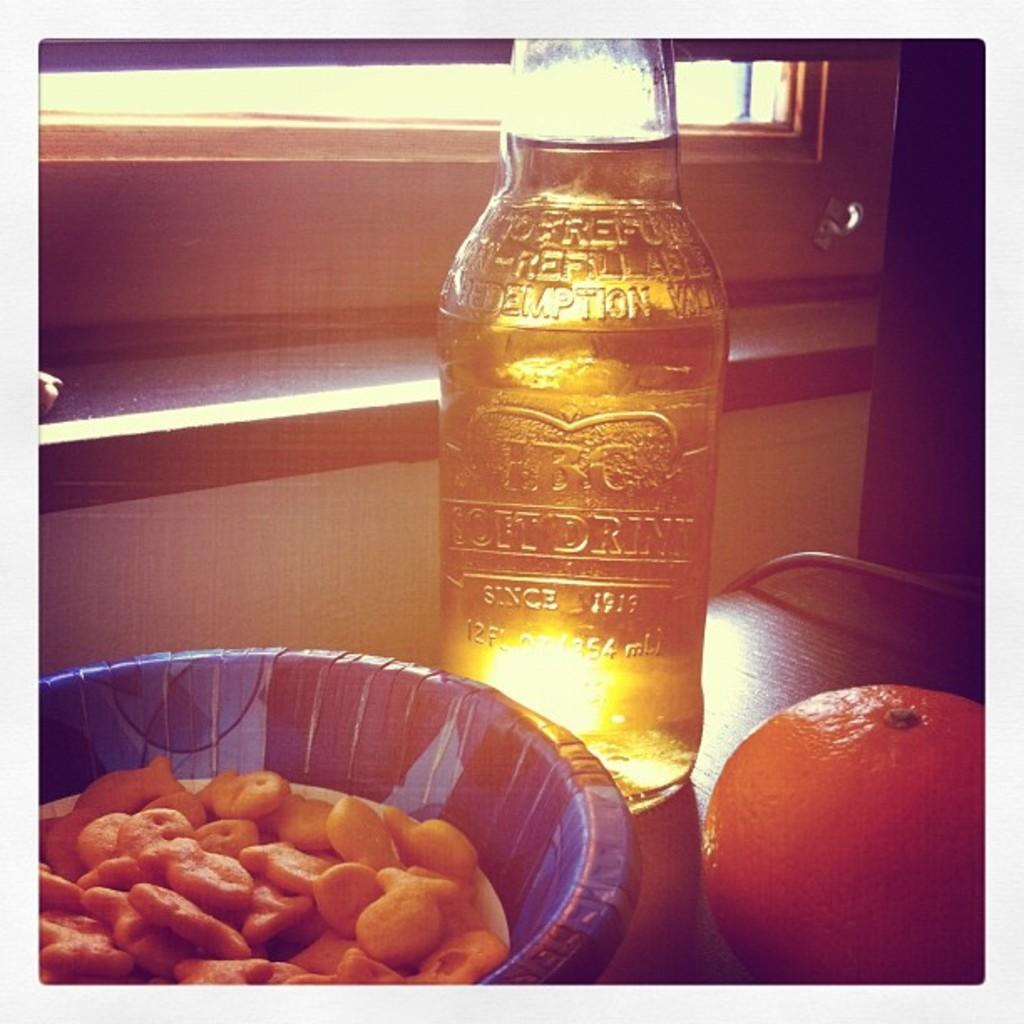What is in the bowl that is visible in the image? The bowl contains snacks. What other items can be seen on the table in the image? There is a wine bottle and an orange on the table. What might be used for drinking in the image? The wine bottle on the table might be used for drinking. What type of fruit is present on the table in the image? There is an orange on the table. Is there a ball being juggled by a clown in the image? No, there is no ball or clown present in the image. 